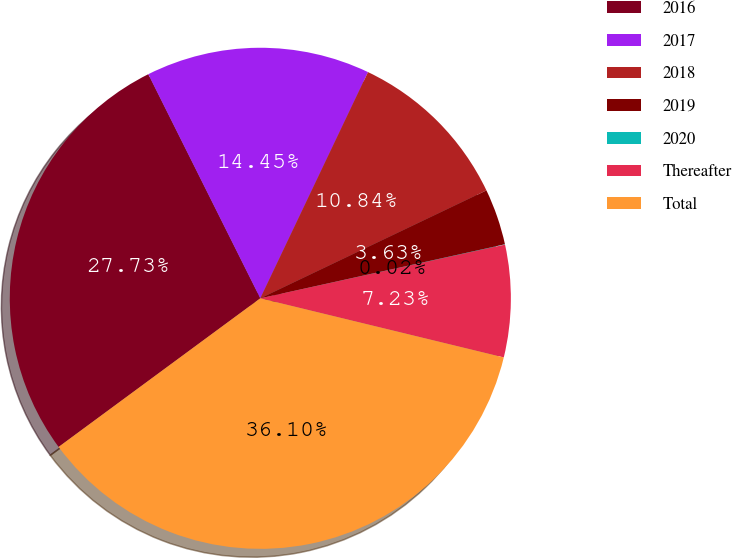Convert chart to OTSL. <chart><loc_0><loc_0><loc_500><loc_500><pie_chart><fcel>2016<fcel>2017<fcel>2018<fcel>2019<fcel>2020<fcel>Thereafter<fcel>Total<nl><fcel>27.73%<fcel>14.45%<fcel>10.84%<fcel>3.63%<fcel>0.02%<fcel>7.23%<fcel>36.1%<nl></chart> 